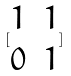Convert formula to latex. <formula><loc_0><loc_0><loc_500><loc_500>[ \begin{matrix} 1 & 1 \\ 0 & 1 \end{matrix} ]</formula> 